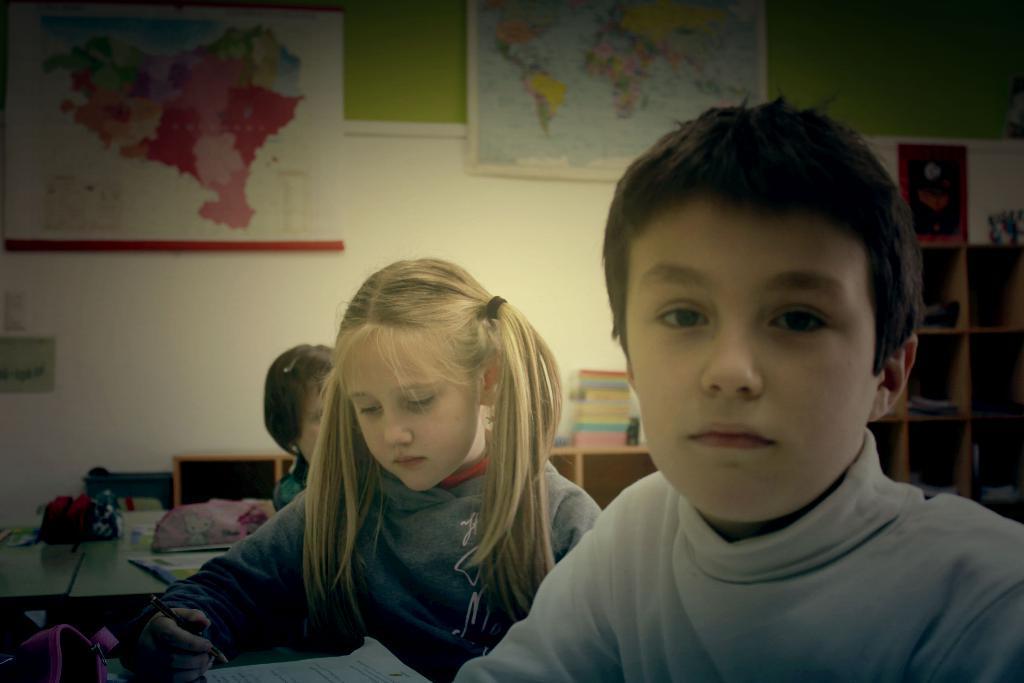Describe this image in one or two sentences. In this image we can see children sitting on the chairs and tables are placed in front of them. On the tables we can see papers, pouches and pens. In the background we can see maps hanged to the walls and books arranged in different shelves. 